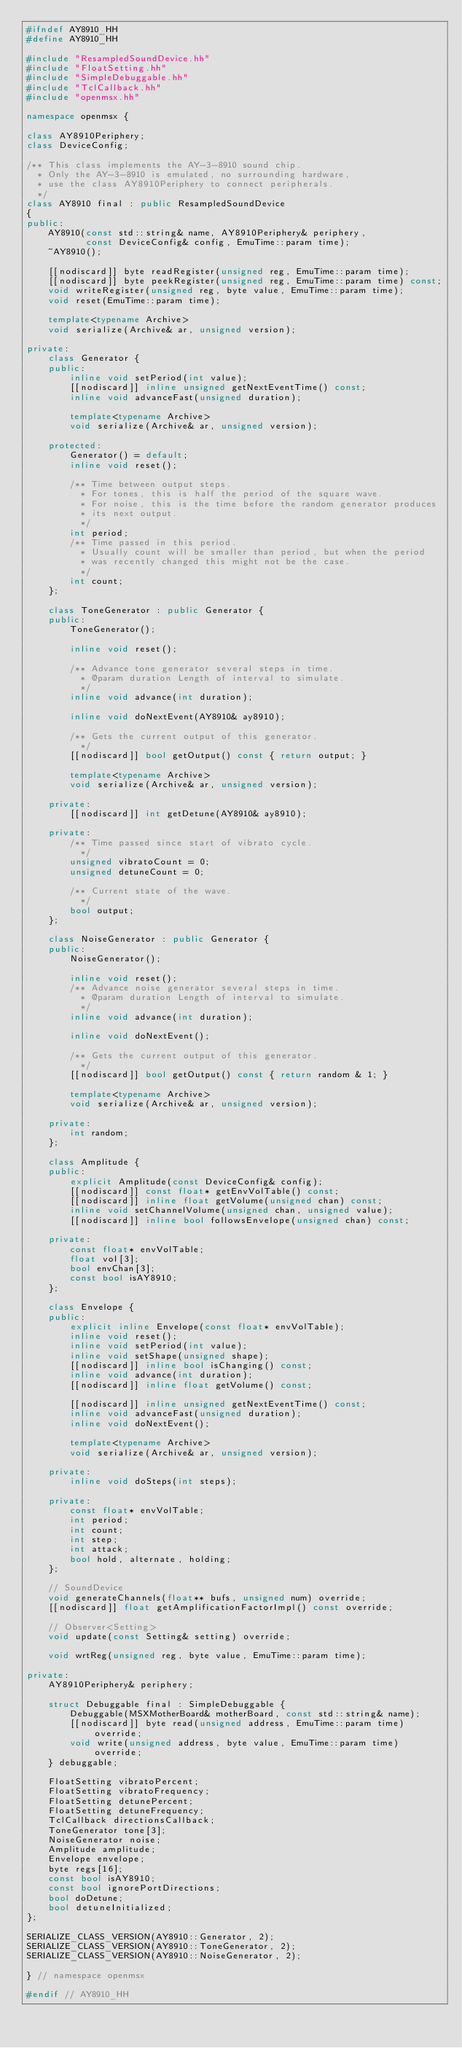Convert code to text. <code><loc_0><loc_0><loc_500><loc_500><_C++_>#ifndef AY8910_HH
#define AY8910_HH

#include "ResampledSoundDevice.hh"
#include "FloatSetting.hh"
#include "SimpleDebuggable.hh"
#include "TclCallback.hh"
#include "openmsx.hh"

namespace openmsx {

class AY8910Periphery;
class DeviceConfig;

/** This class implements the AY-3-8910 sound chip.
  * Only the AY-3-8910 is emulated, no surrounding hardware,
  * use the class AY8910Periphery to connect peripherals.
  */
class AY8910 final : public ResampledSoundDevice
{
public:
	AY8910(const std::string& name, AY8910Periphery& periphery,
	       const DeviceConfig& config, EmuTime::param time);
	~AY8910();

	[[nodiscard]] byte readRegister(unsigned reg, EmuTime::param time);
	[[nodiscard]] byte peekRegister(unsigned reg, EmuTime::param time) const;
	void writeRegister(unsigned reg, byte value, EmuTime::param time);
	void reset(EmuTime::param time);

	template<typename Archive>
	void serialize(Archive& ar, unsigned version);

private:
	class Generator {
	public:
		inline void setPeriod(int value);
		[[nodiscard]] inline unsigned getNextEventTime() const;
		inline void advanceFast(unsigned duration);

		template<typename Archive>
		void serialize(Archive& ar, unsigned version);

	protected:
		Generator() = default;
		inline void reset();

		/** Time between output steps.
		  * For tones, this is half the period of the square wave.
		  * For noise, this is the time before the random generator produces
		  * its next output.
		  */
		int period;
		/** Time passed in this period.
		  * Usually count will be smaller than period, but when the period
		  * was recently changed this might not be the case.
		  */
		int count;
	};

	class ToneGenerator : public Generator {
	public:
		ToneGenerator();

		inline void reset();

		/** Advance tone generator several steps in time.
		  * @param duration Length of interval to simulate.
		  */
		inline void advance(int duration);

		inline void doNextEvent(AY8910& ay8910);

		/** Gets the current output of this generator.
		  */
		[[nodiscard]] bool getOutput() const { return output; }

		template<typename Archive>
		void serialize(Archive& ar, unsigned version);

	private:
		[[nodiscard]] int getDetune(AY8910& ay8910);

	private:
		/** Time passed since start of vibrato cycle.
		  */
		unsigned vibratoCount = 0;
		unsigned detuneCount = 0;

		/** Current state of the wave.
		  */
		bool output;
	};

	class NoiseGenerator : public Generator {
	public:
		NoiseGenerator();

		inline void reset();
		/** Advance noise generator several steps in time.
		  * @param duration Length of interval to simulate.
		  */
		inline void advance(int duration);

		inline void doNextEvent();

		/** Gets the current output of this generator.
		  */
		[[nodiscard]] bool getOutput() const { return random & 1; }

		template<typename Archive>
		void serialize(Archive& ar, unsigned version);

	private:
		int random;
	};

	class Amplitude {
	public:
		explicit Amplitude(const DeviceConfig& config);
		[[nodiscard]] const float* getEnvVolTable() const;
		[[nodiscard]] inline float getVolume(unsigned chan) const;
		inline void setChannelVolume(unsigned chan, unsigned value);
		[[nodiscard]] inline bool followsEnvelope(unsigned chan) const;

	private:
		const float* envVolTable;
		float vol[3];
		bool envChan[3];
		const bool isAY8910;
	};

	class Envelope {
	public:
		explicit inline Envelope(const float* envVolTable);
		inline void reset();
		inline void setPeriod(int value);
		inline void setShape(unsigned shape);
		[[nodiscard]] inline bool isChanging() const;
		inline void advance(int duration);
		[[nodiscard]] inline float getVolume() const;

		[[nodiscard]] inline unsigned getNextEventTime() const;
		inline void advanceFast(unsigned duration);
		inline void doNextEvent();

		template<typename Archive>
		void serialize(Archive& ar, unsigned version);

	private:
		inline void doSteps(int steps);

	private:
		const float* envVolTable;
		int period;
		int count;
		int step;
		int attack;
		bool hold, alternate, holding;
	};

	// SoundDevice
	void generateChannels(float** bufs, unsigned num) override;
	[[nodiscard]] float getAmplificationFactorImpl() const override;

	// Observer<Setting>
	void update(const Setting& setting) override;

	void wrtReg(unsigned reg, byte value, EmuTime::param time);

private:
	AY8910Periphery& periphery;

	struct Debuggable final : SimpleDebuggable {
		Debuggable(MSXMotherBoard& motherBoard, const std::string& name);
		[[nodiscard]] byte read(unsigned address, EmuTime::param time) override;
		void write(unsigned address, byte value, EmuTime::param time) override;
	} debuggable;

	FloatSetting vibratoPercent;
	FloatSetting vibratoFrequency;
	FloatSetting detunePercent;
	FloatSetting detuneFrequency;
	TclCallback directionsCallback;
	ToneGenerator tone[3];
	NoiseGenerator noise;
	Amplitude amplitude;
	Envelope envelope;
	byte regs[16];
	const bool isAY8910;
	const bool ignorePortDirections;
	bool doDetune;
	bool detuneInitialized;
};

SERIALIZE_CLASS_VERSION(AY8910::Generator, 2);
SERIALIZE_CLASS_VERSION(AY8910::ToneGenerator, 2);
SERIALIZE_CLASS_VERSION(AY8910::NoiseGenerator, 2);

} // namespace openmsx

#endif // AY8910_HH
</code> 